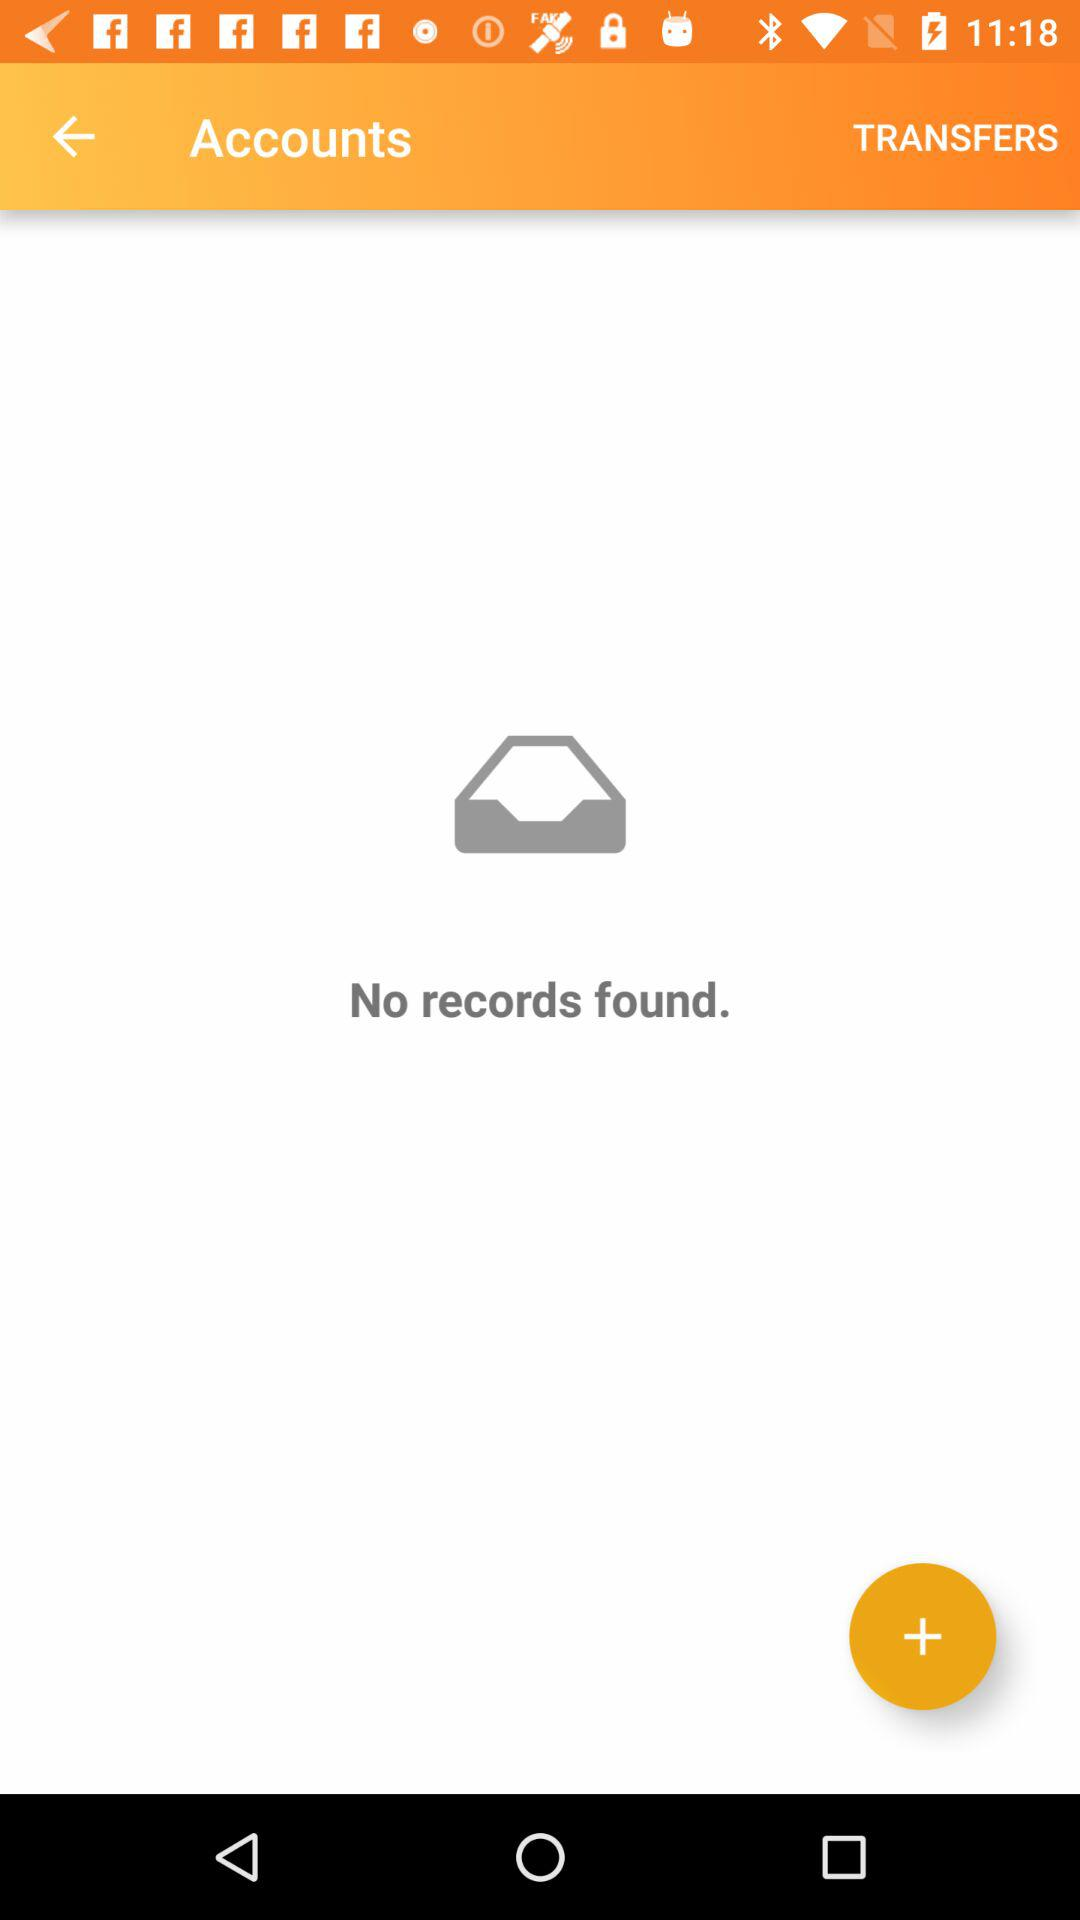How many records were found? There were no records found. 